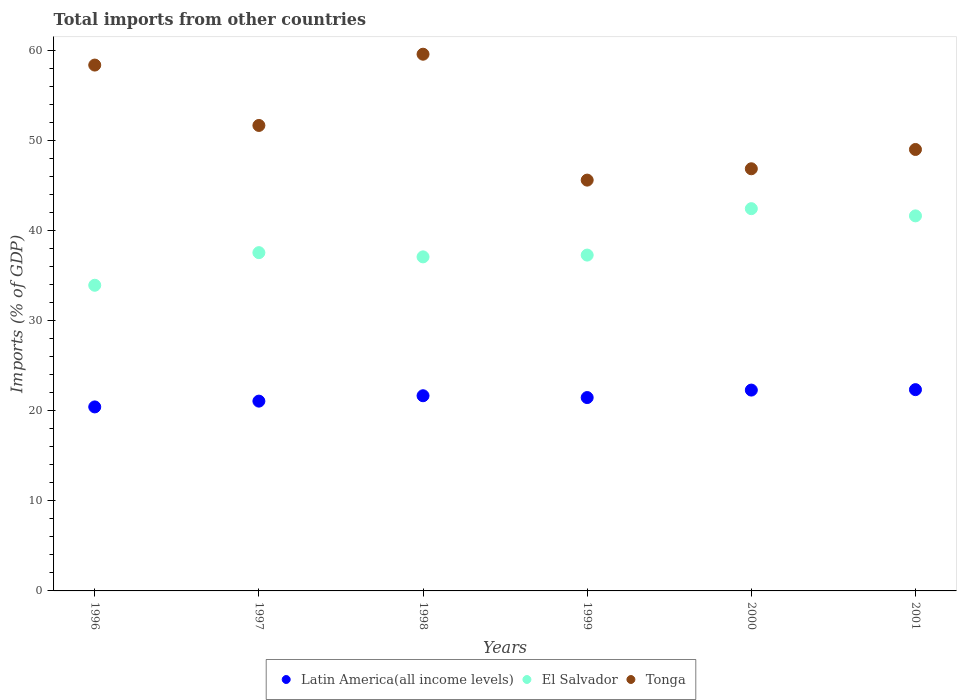How many different coloured dotlines are there?
Your answer should be very brief. 3. Is the number of dotlines equal to the number of legend labels?
Keep it short and to the point. Yes. What is the total imports in Latin America(all income levels) in 2000?
Give a very brief answer. 22.3. Across all years, what is the maximum total imports in El Salvador?
Offer a very short reply. 42.43. Across all years, what is the minimum total imports in El Salvador?
Provide a short and direct response. 33.93. What is the total total imports in Latin America(all income levels) in the graph?
Provide a succinct answer. 129.27. What is the difference between the total imports in El Salvador in 1997 and that in 1999?
Offer a very short reply. 0.27. What is the difference between the total imports in El Salvador in 1998 and the total imports in Tonga in 2000?
Provide a short and direct response. -9.78. What is the average total imports in Tonga per year?
Offer a terse response. 51.85. In the year 1999, what is the difference between the total imports in Latin America(all income levels) and total imports in El Salvador?
Offer a terse response. -15.82. What is the ratio of the total imports in Latin America(all income levels) in 1997 to that in 1998?
Provide a short and direct response. 0.97. Is the total imports in Tonga in 1997 less than that in 1999?
Offer a terse response. No. What is the difference between the highest and the second highest total imports in Tonga?
Ensure brevity in your answer.  1.21. What is the difference between the highest and the lowest total imports in El Salvador?
Your answer should be compact. 8.5. In how many years, is the total imports in Latin America(all income levels) greater than the average total imports in Latin America(all income levels) taken over all years?
Your answer should be very brief. 3. Is the sum of the total imports in Tonga in 1996 and 2001 greater than the maximum total imports in Latin America(all income levels) across all years?
Give a very brief answer. Yes. Is it the case that in every year, the sum of the total imports in El Salvador and total imports in Latin America(all income levels)  is greater than the total imports in Tonga?
Offer a terse response. No. Is the total imports in Tonga strictly greater than the total imports in Latin America(all income levels) over the years?
Keep it short and to the point. Yes. How many dotlines are there?
Offer a very short reply. 3. How many years are there in the graph?
Your answer should be very brief. 6. What is the difference between two consecutive major ticks on the Y-axis?
Your response must be concise. 10. Where does the legend appear in the graph?
Your response must be concise. Bottom center. How many legend labels are there?
Provide a succinct answer. 3. What is the title of the graph?
Offer a terse response. Total imports from other countries. Does "Russian Federation" appear as one of the legend labels in the graph?
Offer a terse response. No. What is the label or title of the Y-axis?
Make the answer very short. Imports (% of GDP). What is the Imports (% of GDP) of Latin America(all income levels) in 1996?
Ensure brevity in your answer.  20.43. What is the Imports (% of GDP) in El Salvador in 1996?
Your answer should be very brief. 33.93. What is the Imports (% of GDP) in Tonga in 1996?
Ensure brevity in your answer.  58.38. What is the Imports (% of GDP) in Latin America(all income levels) in 1997?
Offer a very short reply. 21.07. What is the Imports (% of GDP) in El Salvador in 1997?
Your response must be concise. 37.55. What is the Imports (% of GDP) of Tonga in 1997?
Keep it short and to the point. 51.67. What is the Imports (% of GDP) of Latin America(all income levels) in 1998?
Your answer should be compact. 21.67. What is the Imports (% of GDP) of El Salvador in 1998?
Provide a short and direct response. 37.08. What is the Imports (% of GDP) in Tonga in 1998?
Make the answer very short. 59.58. What is the Imports (% of GDP) in Latin America(all income levels) in 1999?
Make the answer very short. 21.47. What is the Imports (% of GDP) of El Salvador in 1999?
Make the answer very short. 37.28. What is the Imports (% of GDP) of Tonga in 1999?
Your answer should be very brief. 45.6. What is the Imports (% of GDP) of Latin America(all income levels) in 2000?
Your answer should be compact. 22.3. What is the Imports (% of GDP) of El Salvador in 2000?
Offer a terse response. 42.43. What is the Imports (% of GDP) of Tonga in 2000?
Offer a terse response. 46.86. What is the Imports (% of GDP) in Latin America(all income levels) in 2001?
Your answer should be compact. 22.34. What is the Imports (% of GDP) of El Salvador in 2001?
Offer a terse response. 41.63. What is the Imports (% of GDP) of Tonga in 2001?
Offer a terse response. 49.01. Across all years, what is the maximum Imports (% of GDP) in Latin America(all income levels)?
Provide a succinct answer. 22.34. Across all years, what is the maximum Imports (% of GDP) of El Salvador?
Ensure brevity in your answer.  42.43. Across all years, what is the maximum Imports (% of GDP) in Tonga?
Provide a succinct answer. 59.58. Across all years, what is the minimum Imports (% of GDP) of Latin America(all income levels)?
Offer a very short reply. 20.43. Across all years, what is the minimum Imports (% of GDP) of El Salvador?
Keep it short and to the point. 33.93. Across all years, what is the minimum Imports (% of GDP) of Tonga?
Your answer should be compact. 45.6. What is the total Imports (% of GDP) in Latin America(all income levels) in the graph?
Your answer should be compact. 129.27. What is the total Imports (% of GDP) of El Salvador in the graph?
Make the answer very short. 229.92. What is the total Imports (% of GDP) of Tonga in the graph?
Make the answer very short. 311.1. What is the difference between the Imports (% of GDP) in Latin America(all income levels) in 1996 and that in 1997?
Give a very brief answer. -0.64. What is the difference between the Imports (% of GDP) of El Salvador in 1996 and that in 1997?
Your answer should be very brief. -3.62. What is the difference between the Imports (% of GDP) of Tonga in 1996 and that in 1997?
Ensure brevity in your answer.  6.7. What is the difference between the Imports (% of GDP) in Latin America(all income levels) in 1996 and that in 1998?
Give a very brief answer. -1.24. What is the difference between the Imports (% of GDP) of El Salvador in 1996 and that in 1998?
Your answer should be compact. -3.15. What is the difference between the Imports (% of GDP) of Tonga in 1996 and that in 1998?
Make the answer very short. -1.21. What is the difference between the Imports (% of GDP) in Latin America(all income levels) in 1996 and that in 1999?
Your response must be concise. -1.04. What is the difference between the Imports (% of GDP) in El Salvador in 1996 and that in 1999?
Make the answer very short. -3.35. What is the difference between the Imports (% of GDP) of Tonga in 1996 and that in 1999?
Keep it short and to the point. 12.77. What is the difference between the Imports (% of GDP) in Latin America(all income levels) in 1996 and that in 2000?
Your answer should be compact. -1.87. What is the difference between the Imports (% of GDP) of El Salvador in 1996 and that in 2000?
Give a very brief answer. -8.5. What is the difference between the Imports (% of GDP) in Tonga in 1996 and that in 2000?
Provide a short and direct response. 11.51. What is the difference between the Imports (% of GDP) of Latin America(all income levels) in 1996 and that in 2001?
Make the answer very short. -1.92. What is the difference between the Imports (% of GDP) in El Salvador in 1996 and that in 2001?
Offer a very short reply. -7.7. What is the difference between the Imports (% of GDP) in Tonga in 1996 and that in 2001?
Keep it short and to the point. 9.37. What is the difference between the Imports (% of GDP) of Latin America(all income levels) in 1997 and that in 1998?
Your answer should be compact. -0.6. What is the difference between the Imports (% of GDP) of El Salvador in 1997 and that in 1998?
Your response must be concise. 0.47. What is the difference between the Imports (% of GDP) of Tonga in 1997 and that in 1998?
Offer a terse response. -7.91. What is the difference between the Imports (% of GDP) of Latin America(all income levels) in 1997 and that in 1999?
Give a very brief answer. -0.4. What is the difference between the Imports (% of GDP) of El Salvador in 1997 and that in 1999?
Ensure brevity in your answer.  0.27. What is the difference between the Imports (% of GDP) of Tonga in 1997 and that in 1999?
Ensure brevity in your answer.  6.07. What is the difference between the Imports (% of GDP) in Latin America(all income levels) in 1997 and that in 2000?
Your answer should be very brief. -1.23. What is the difference between the Imports (% of GDP) of El Salvador in 1997 and that in 2000?
Your answer should be very brief. -4.88. What is the difference between the Imports (% of GDP) of Tonga in 1997 and that in 2000?
Offer a very short reply. 4.81. What is the difference between the Imports (% of GDP) in Latin America(all income levels) in 1997 and that in 2001?
Give a very brief answer. -1.28. What is the difference between the Imports (% of GDP) of El Salvador in 1997 and that in 2001?
Keep it short and to the point. -4.08. What is the difference between the Imports (% of GDP) of Tonga in 1997 and that in 2001?
Provide a short and direct response. 2.67. What is the difference between the Imports (% of GDP) in Latin America(all income levels) in 1998 and that in 1999?
Your answer should be very brief. 0.2. What is the difference between the Imports (% of GDP) of El Salvador in 1998 and that in 1999?
Give a very brief answer. -0.2. What is the difference between the Imports (% of GDP) in Tonga in 1998 and that in 1999?
Your response must be concise. 13.98. What is the difference between the Imports (% of GDP) of Latin America(all income levels) in 1998 and that in 2000?
Keep it short and to the point. -0.63. What is the difference between the Imports (% of GDP) in El Salvador in 1998 and that in 2000?
Keep it short and to the point. -5.35. What is the difference between the Imports (% of GDP) of Tonga in 1998 and that in 2000?
Offer a terse response. 12.72. What is the difference between the Imports (% of GDP) in Latin America(all income levels) in 1998 and that in 2001?
Offer a very short reply. -0.68. What is the difference between the Imports (% of GDP) in El Salvador in 1998 and that in 2001?
Make the answer very short. -4.55. What is the difference between the Imports (% of GDP) in Tonga in 1998 and that in 2001?
Provide a succinct answer. 10.58. What is the difference between the Imports (% of GDP) in Latin America(all income levels) in 1999 and that in 2000?
Ensure brevity in your answer.  -0.83. What is the difference between the Imports (% of GDP) in El Salvador in 1999 and that in 2000?
Provide a succinct answer. -5.15. What is the difference between the Imports (% of GDP) in Tonga in 1999 and that in 2000?
Your response must be concise. -1.26. What is the difference between the Imports (% of GDP) in Latin America(all income levels) in 1999 and that in 2001?
Provide a succinct answer. -0.88. What is the difference between the Imports (% of GDP) in El Salvador in 1999 and that in 2001?
Provide a short and direct response. -4.35. What is the difference between the Imports (% of GDP) of Tonga in 1999 and that in 2001?
Keep it short and to the point. -3.4. What is the difference between the Imports (% of GDP) of Latin America(all income levels) in 2000 and that in 2001?
Give a very brief answer. -0.05. What is the difference between the Imports (% of GDP) in El Salvador in 2000 and that in 2001?
Your response must be concise. 0.8. What is the difference between the Imports (% of GDP) in Tonga in 2000 and that in 2001?
Provide a succinct answer. -2.14. What is the difference between the Imports (% of GDP) of Latin America(all income levels) in 1996 and the Imports (% of GDP) of El Salvador in 1997?
Provide a succinct answer. -17.13. What is the difference between the Imports (% of GDP) in Latin America(all income levels) in 1996 and the Imports (% of GDP) in Tonga in 1997?
Offer a very short reply. -31.25. What is the difference between the Imports (% of GDP) of El Salvador in 1996 and the Imports (% of GDP) of Tonga in 1997?
Offer a terse response. -17.74. What is the difference between the Imports (% of GDP) of Latin America(all income levels) in 1996 and the Imports (% of GDP) of El Salvador in 1998?
Offer a very short reply. -16.66. What is the difference between the Imports (% of GDP) in Latin America(all income levels) in 1996 and the Imports (% of GDP) in Tonga in 1998?
Provide a short and direct response. -39.15. What is the difference between the Imports (% of GDP) in El Salvador in 1996 and the Imports (% of GDP) in Tonga in 1998?
Your answer should be compact. -25.65. What is the difference between the Imports (% of GDP) of Latin America(all income levels) in 1996 and the Imports (% of GDP) of El Salvador in 1999?
Offer a terse response. -16.86. What is the difference between the Imports (% of GDP) of Latin America(all income levels) in 1996 and the Imports (% of GDP) of Tonga in 1999?
Offer a terse response. -25.18. What is the difference between the Imports (% of GDP) in El Salvador in 1996 and the Imports (% of GDP) in Tonga in 1999?
Offer a very short reply. -11.67. What is the difference between the Imports (% of GDP) of Latin America(all income levels) in 1996 and the Imports (% of GDP) of El Salvador in 2000?
Your response must be concise. -22.01. What is the difference between the Imports (% of GDP) of Latin America(all income levels) in 1996 and the Imports (% of GDP) of Tonga in 2000?
Provide a short and direct response. -26.44. What is the difference between the Imports (% of GDP) of El Salvador in 1996 and the Imports (% of GDP) of Tonga in 2000?
Your answer should be very brief. -12.93. What is the difference between the Imports (% of GDP) of Latin America(all income levels) in 1996 and the Imports (% of GDP) of El Salvador in 2001?
Make the answer very short. -21.21. What is the difference between the Imports (% of GDP) of Latin America(all income levels) in 1996 and the Imports (% of GDP) of Tonga in 2001?
Your answer should be compact. -28.58. What is the difference between the Imports (% of GDP) of El Salvador in 1996 and the Imports (% of GDP) of Tonga in 2001?
Your answer should be compact. -15.07. What is the difference between the Imports (% of GDP) in Latin America(all income levels) in 1997 and the Imports (% of GDP) in El Salvador in 1998?
Make the answer very short. -16.01. What is the difference between the Imports (% of GDP) in Latin America(all income levels) in 1997 and the Imports (% of GDP) in Tonga in 1998?
Give a very brief answer. -38.51. What is the difference between the Imports (% of GDP) of El Salvador in 1997 and the Imports (% of GDP) of Tonga in 1998?
Your response must be concise. -22.03. What is the difference between the Imports (% of GDP) of Latin America(all income levels) in 1997 and the Imports (% of GDP) of El Salvador in 1999?
Your answer should be very brief. -16.21. What is the difference between the Imports (% of GDP) in Latin America(all income levels) in 1997 and the Imports (% of GDP) in Tonga in 1999?
Provide a short and direct response. -24.54. What is the difference between the Imports (% of GDP) of El Salvador in 1997 and the Imports (% of GDP) of Tonga in 1999?
Your answer should be very brief. -8.05. What is the difference between the Imports (% of GDP) of Latin America(all income levels) in 1997 and the Imports (% of GDP) of El Salvador in 2000?
Provide a short and direct response. -21.37. What is the difference between the Imports (% of GDP) of Latin America(all income levels) in 1997 and the Imports (% of GDP) of Tonga in 2000?
Ensure brevity in your answer.  -25.79. What is the difference between the Imports (% of GDP) in El Salvador in 1997 and the Imports (% of GDP) in Tonga in 2000?
Give a very brief answer. -9.31. What is the difference between the Imports (% of GDP) of Latin America(all income levels) in 1997 and the Imports (% of GDP) of El Salvador in 2001?
Provide a short and direct response. -20.57. What is the difference between the Imports (% of GDP) in Latin America(all income levels) in 1997 and the Imports (% of GDP) in Tonga in 2001?
Your response must be concise. -27.94. What is the difference between the Imports (% of GDP) of El Salvador in 1997 and the Imports (% of GDP) of Tonga in 2001?
Provide a succinct answer. -11.45. What is the difference between the Imports (% of GDP) in Latin America(all income levels) in 1998 and the Imports (% of GDP) in El Salvador in 1999?
Make the answer very short. -15.61. What is the difference between the Imports (% of GDP) in Latin America(all income levels) in 1998 and the Imports (% of GDP) in Tonga in 1999?
Offer a terse response. -23.94. What is the difference between the Imports (% of GDP) of El Salvador in 1998 and the Imports (% of GDP) of Tonga in 1999?
Keep it short and to the point. -8.52. What is the difference between the Imports (% of GDP) of Latin America(all income levels) in 1998 and the Imports (% of GDP) of El Salvador in 2000?
Offer a terse response. -20.77. What is the difference between the Imports (% of GDP) in Latin America(all income levels) in 1998 and the Imports (% of GDP) in Tonga in 2000?
Give a very brief answer. -25.2. What is the difference between the Imports (% of GDP) of El Salvador in 1998 and the Imports (% of GDP) of Tonga in 2000?
Provide a short and direct response. -9.78. What is the difference between the Imports (% of GDP) in Latin America(all income levels) in 1998 and the Imports (% of GDP) in El Salvador in 2001?
Your answer should be compact. -19.97. What is the difference between the Imports (% of GDP) in Latin America(all income levels) in 1998 and the Imports (% of GDP) in Tonga in 2001?
Ensure brevity in your answer.  -27.34. What is the difference between the Imports (% of GDP) of El Salvador in 1998 and the Imports (% of GDP) of Tonga in 2001?
Offer a very short reply. -11.92. What is the difference between the Imports (% of GDP) of Latin America(all income levels) in 1999 and the Imports (% of GDP) of El Salvador in 2000?
Provide a succinct answer. -20.97. What is the difference between the Imports (% of GDP) of Latin America(all income levels) in 1999 and the Imports (% of GDP) of Tonga in 2000?
Keep it short and to the point. -25.4. What is the difference between the Imports (% of GDP) in El Salvador in 1999 and the Imports (% of GDP) in Tonga in 2000?
Your response must be concise. -9.58. What is the difference between the Imports (% of GDP) in Latin America(all income levels) in 1999 and the Imports (% of GDP) in El Salvador in 2001?
Your response must be concise. -20.17. What is the difference between the Imports (% of GDP) in Latin America(all income levels) in 1999 and the Imports (% of GDP) in Tonga in 2001?
Provide a short and direct response. -27.54. What is the difference between the Imports (% of GDP) in El Salvador in 1999 and the Imports (% of GDP) in Tonga in 2001?
Provide a succinct answer. -11.72. What is the difference between the Imports (% of GDP) in Latin America(all income levels) in 2000 and the Imports (% of GDP) in El Salvador in 2001?
Ensure brevity in your answer.  -19.34. What is the difference between the Imports (% of GDP) of Latin America(all income levels) in 2000 and the Imports (% of GDP) of Tonga in 2001?
Your response must be concise. -26.71. What is the difference between the Imports (% of GDP) in El Salvador in 2000 and the Imports (% of GDP) in Tonga in 2001?
Offer a terse response. -6.57. What is the average Imports (% of GDP) of Latin America(all income levels) per year?
Ensure brevity in your answer.  21.54. What is the average Imports (% of GDP) in El Salvador per year?
Provide a succinct answer. 38.32. What is the average Imports (% of GDP) of Tonga per year?
Give a very brief answer. 51.85. In the year 1996, what is the difference between the Imports (% of GDP) of Latin America(all income levels) and Imports (% of GDP) of El Salvador?
Give a very brief answer. -13.51. In the year 1996, what is the difference between the Imports (% of GDP) of Latin America(all income levels) and Imports (% of GDP) of Tonga?
Your response must be concise. -37.95. In the year 1996, what is the difference between the Imports (% of GDP) of El Salvador and Imports (% of GDP) of Tonga?
Give a very brief answer. -24.44. In the year 1997, what is the difference between the Imports (% of GDP) in Latin America(all income levels) and Imports (% of GDP) in El Salvador?
Provide a short and direct response. -16.48. In the year 1997, what is the difference between the Imports (% of GDP) of Latin America(all income levels) and Imports (% of GDP) of Tonga?
Ensure brevity in your answer.  -30.6. In the year 1997, what is the difference between the Imports (% of GDP) of El Salvador and Imports (% of GDP) of Tonga?
Your response must be concise. -14.12. In the year 1998, what is the difference between the Imports (% of GDP) of Latin America(all income levels) and Imports (% of GDP) of El Salvador?
Provide a succinct answer. -15.42. In the year 1998, what is the difference between the Imports (% of GDP) in Latin America(all income levels) and Imports (% of GDP) in Tonga?
Give a very brief answer. -37.91. In the year 1998, what is the difference between the Imports (% of GDP) in El Salvador and Imports (% of GDP) in Tonga?
Your answer should be very brief. -22.5. In the year 1999, what is the difference between the Imports (% of GDP) of Latin America(all income levels) and Imports (% of GDP) of El Salvador?
Keep it short and to the point. -15.82. In the year 1999, what is the difference between the Imports (% of GDP) of Latin America(all income levels) and Imports (% of GDP) of Tonga?
Provide a succinct answer. -24.14. In the year 1999, what is the difference between the Imports (% of GDP) of El Salvador and Imports (% of GDP) of Tonga?
Ensure brevity in your answer.  -8.32. In the year 2000, what is the difference between the Imports (% of GDP) of Latin America(all income levels) and Imports (% of GDP) of El Salvador?
Your answer should be very brief. -20.14. In the year 2000, what is the difference between the Imports (% of GDP) in Latin America(all income levels) and Imports (% of GDP) in Tonga?
Offer a very short reply. -24.57. In the year 2000, what is the difference between the Imports (% of GDP) of El Salvador and Imports (% of GDP) of Tonga?
Ensure brevity in your answer.  -4.43. In the year 2001, what is the difference between the Imports (% of GDP) of Latin America(all income levels) and Imports (% of GDP) of El Salvador?
Make the answer very short. -19.29. In the year 2001, what is the difference between the Imports (% of GDP) of Latin America(all income levels) and Imports (% of GDP) of Tonga?
Provide a short and direct response. -26.66. In the year 2001, what is the difference between the Imports (% of GDP) of El Salvador and Imports (% of GDP) of Tonga?
Ensure brevity in your answer.  -7.37. What is the ratio of the Imports (% of GDP) of Latin America(all income levels) in 1996 to that in 1997?
Offer a terse response. 0.97. What is the ratio of the Imports (% of GDP) of El Salvador in 1996 to that in 1997?
Offer a very short reply. 0.9. What is the ratio of the Imports (% of GDP) in Tonga in 1996 to that in 1997?
Offer a terse response. 1.13. What is the ratio of the Imports (% of GDP) of Latin America(all income levels) in 1996 to that in 1998?
Make the answer very short. 0.94. What is the ratio of the Imports (% of GDP) of El Salvador in 1996 to that in 1998?
Offer a very short reply. 0.92. What is the ratio of the Imports (% of GDP) of Tonga in 1996 to that in 1998?
Make the answer very short. 0.98. What is the ratio of the Imports (% of GDP) in Latin America(all income levels) in 1996 to that in 1999?
Give a very brief answer. 0.95. What is the ratio of the Imports (% of GDP) in El Salvador in 1996 to that in 1999?
Keep it short and to the point. 0.91. What is the ratio of the Imports (% of GDP) of Tonga in 1996 to that in 1999?
Ensure brevity in your answer.  1.28. What is the ratio of the Imports (% of GDP) of Latin America(all income levels) in 1996 to that in 2000?
Your answer should be compact. 0.92. What is the ratio of the Imports (% of GDP) of El Salvador in 1996 to that in 2000?
Keep it short and to the point. 0.8. What is the ratio of the Imports (% of GDP) of Tonga in 1996 to that in 2000?
Give a very brief answer. 1.25. What is the ratio of the Imports (% of GDP) of Latin America(all income levels) in 1996 to that in 2001?
Keep it short and to the point. 0.91. What is the ratio of the Imports (% of GDP) in El Salvador in 1996 to that in 2001?
Offer a very short reply. 0.81. What is the ratio of the Imports (% of GDP) in Tonga in 1996 to that in 2001?
Make the answer very short. 1.19. What is the ratio of the Imports (% of GDP) of Latin America(all income levels) in 1997 to that in 1998?
Your response must be concise. 0.97. What is the ratio of the Imports (% of GDP) of El Salvador in 1997 to that in 1998?
Provide a succinct answer. 1.01. What is the ratio of the Imports (% of GDP) in Tonga in 1997 to that in 1998?
Provide a succinct answer. 0.87. What is the ratio of the Imports (% of GDP) in Latin America(all income levels) in 1997 to that in 1999?
Keep it short and to the point. 0.98. What is the ratio of the Imports (% of GDP) of El Salvador in 1997 to that in 1999?
Make the answer very short. 1.01. What is the ratio of the Imports (% of GDP) in Tonga in 1997 to that in 1999?
Your answer should be compact. 1.13. What is the ratio of the Imports (% of GDP) of Latin America(all income levels) in 1997 to that in 2000?
Offer a very short reply. 0.94. What is the ratio of the Imports (% of GDP) of El Salvador in 1997 to that in 2000?
Your response must be concise. 0.89. What is the ratio of the Imports (% of GDP) in Tonga in 1997 to that in 2000?
Make the answer very short. 1.1. What is the ratio of the Imports (% of GDP) in Latin America(all income levels) in 1997 to that in 2001?
Provide a short and direct response. 0.94. What is the ratio of the Imports (% of GDP) of El Salvador in 1997 to that in 2001?
Provide a succinct answer. 0.9. What is the ratio of the Imports (% of GDP) in Tonga in 1997 to that in 2001?
Your answer should be very brief. 1.05. What is the ratio of the Imports (% of GDP) in Latin America(all income levels) in 1998 to that in 1999?
Your response must be concise. 1.01. What is the ratio of the Imports (% of GDP) in Tonga in 1998 to that in 1999?
Provide a short and direct response. 1.31. What is the ratio of the Imports (% of GDP) of Latin America(all income levels) in 1998 to that in 2000?
Give a very brief answer. 0.97. What is the ratio of the Imports (% of GDP) of El Salvador in 1998 to that in 2000?
Provide a short and direct response. 0.87. What is the ratio of the Imports (% of GDP) of Tonga in 1998 to that in 2000?
Your response must be concise. 1.27. What is the ratio of the Imports (% of GDP) of Latin America(all income levels) in 1998 to that in 2001?
Provide a short and direct response. 0.97. What is the ratio of the Imports (% of GDP) in El Salvador in 1998 to that in 2001?
Provide a short and direct response. 0.89. What is the ratio of the Imports (% of GDP) of Tonga in 1998 to that in 2001?
Make the answer very short. 1.22. What is the ratio of the Imports (% of GDP) in Latin America(all income levels) in 1999 to that in 2000?
Provide a short and direct response. 0.96. What is the ratio of the Imports (% of GDP) in El Salvador in 1999 to that in 2000?
Keep it short and to the point. 0.88. What is the ratio of the Imports (% of GDP) in Tonga in 1999 to that in 2000?
Make the answer very short. 0.97. What is the ratio of the Imports (% of GDP) of Latin America(all income levels) in 1999 to that in 2001?
Make the answer very short. 0.96. What is the ratio of the Imports (% of GDP) of El Salvador in 1999 to that in 2001?
Ensure brevity in your answer.  0.9. What is the ratio of the Imports (% of GDP) of Tonga in 1999 to that in 2001?
Give a very brief answer. 0.93. What is the ratio of the Imports (% of GDP) of El Salvador in 2000 to that in 2001?
Make the answer very short. 1.02. What is the ratio of the Imports (% of GDP) of Tonga in 2000 to that in 2001?
Provide a short and direct response. 0.96. What is the difference between the highest and the second highest Imports (% of GDP) in Latin America(all income levels)?
Provide a succinct answer. 0.05. What is the difference between the highest and the second highest Imports (% of GDP) of El Salvador?
Provide a succinct answer. 0.8. What is the difference between the highest and the second highest Imports (% of GDP) of Tonga?
Offer a very short reply. 1.21. What is the difference between the highest and the lowest Imports (% of GDP) in Latin America(all income levels)?
Keep it short and to the point. 1.92. What is the difference between the highest and the lowest Imports (% of GDP) of El Salvador?
Your response must be concise. 8.5. What is the difference between the highest and the lowest Imports (% of GDP) in Tonga?
Ensure brevity in your answer.  13.98. 